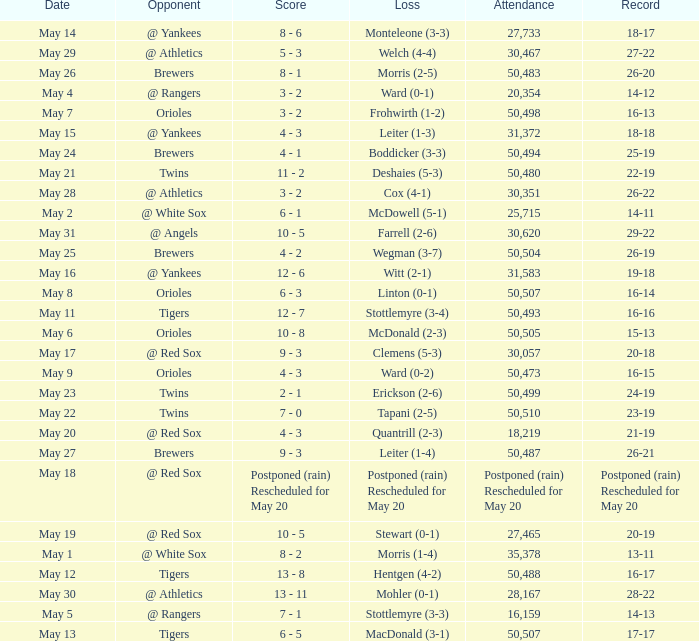On what date was their record 26-19? May 25. 